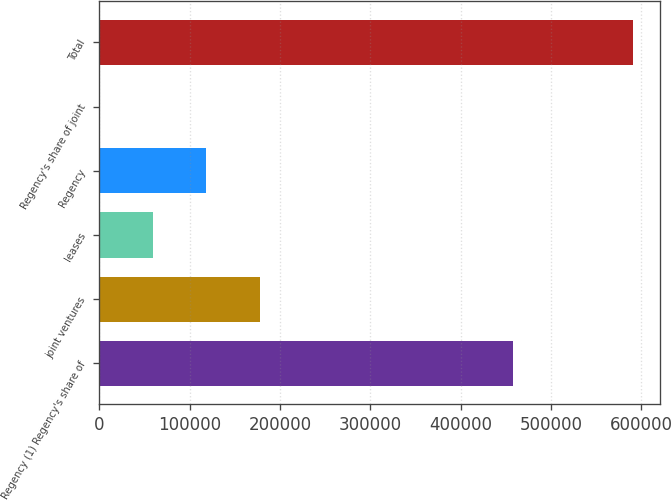Convert chart. <chart><loc_0><loc_0><loc_500><loc_500><bar_chart><fcel>Regency (1) Regency's share of<fcel>joint ventures<fcel>leases<fcel>Regency<fcel>Regency's share of joint<fcel>Total<nl><fcel>457680<fcel>177636<fcel>59474.6<fcel>118555<fcel>394<fcel>591200<nl></chart> 